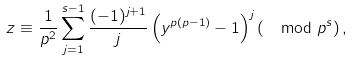<formula> <loc_0><loc_0><loc_500><loc_500>z \equiv \frac { 1 } { p ^ { 2 } } \sum _ { j = 1 } ^ { s - 1 } \frac { ( - 1 ) ^ { j + 1 } } { j } \left ( y ^ { p ( p - 1 ) } - 1 \right ) ^ { j } \left ( \mod p ^ { s } \right ) ,</formula> 